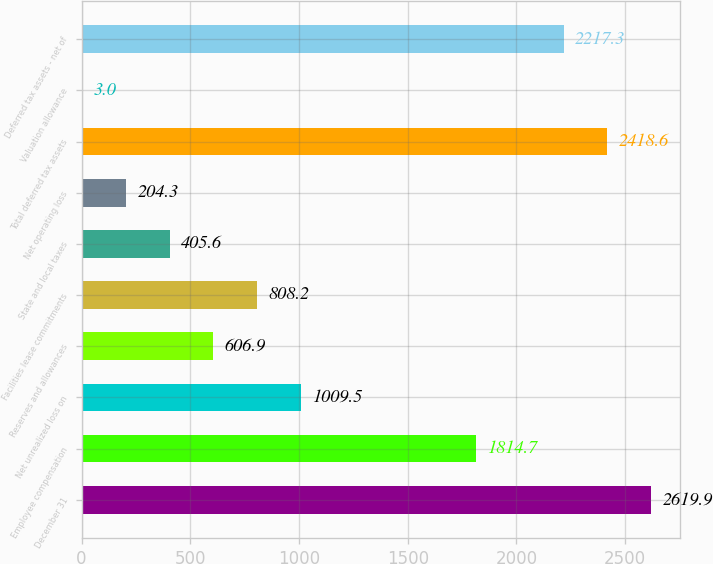Convert chart to OTSL. <chart><loc_0><loc_0><loc_500><loc_500><bar_chart><fcel>December 31<fcel>Employee compensation<fcel>Net unrealized loss on<fcel>Reserves and allowances<fcel>Facilities lease commitments<fcel>State and local taxes<fcel>Net operating loss<fcel>Total deferred tax assets<fcel>Valuation allowance<fcel>Deferred tax assets - net of<nl><fcel>2619.9<fcel>1814.7<fcel>1009.5<fcel>606.9<fcel>808.2<fcel>405.6<fcel>204.3<fcel>2418.6<fcel>3<fcel>2217.3<nl></chart> 